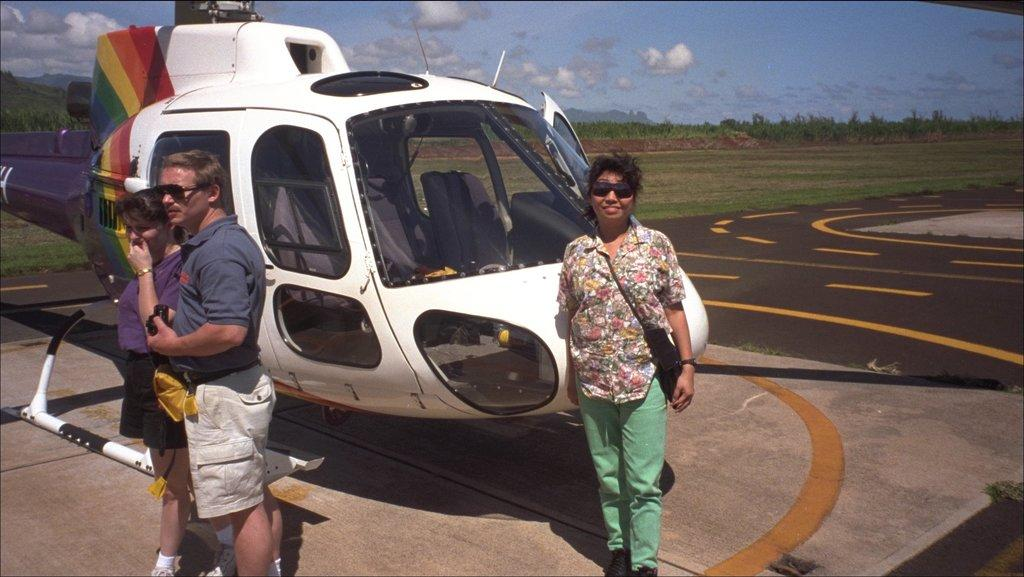What is the woman doing in the image? The woman is standing near a helicopter in the image. What is the woman wearing in the image? The woman is wearing a shirt and trousers in the image. Who else is present in the image? There is a man standing on the left side of the image. What is the man wearing in the image? The man is wearing a t-shirt and shorts in the image. What is visible at the top of the image? The sky is visible at the top of the image. What type of basin can be seen in the image? There is no basin present in the image. Can you describe the woman's smile in the image? The provided facts do not mention the woman's facial expression, so it is not possible to describe her smile. 